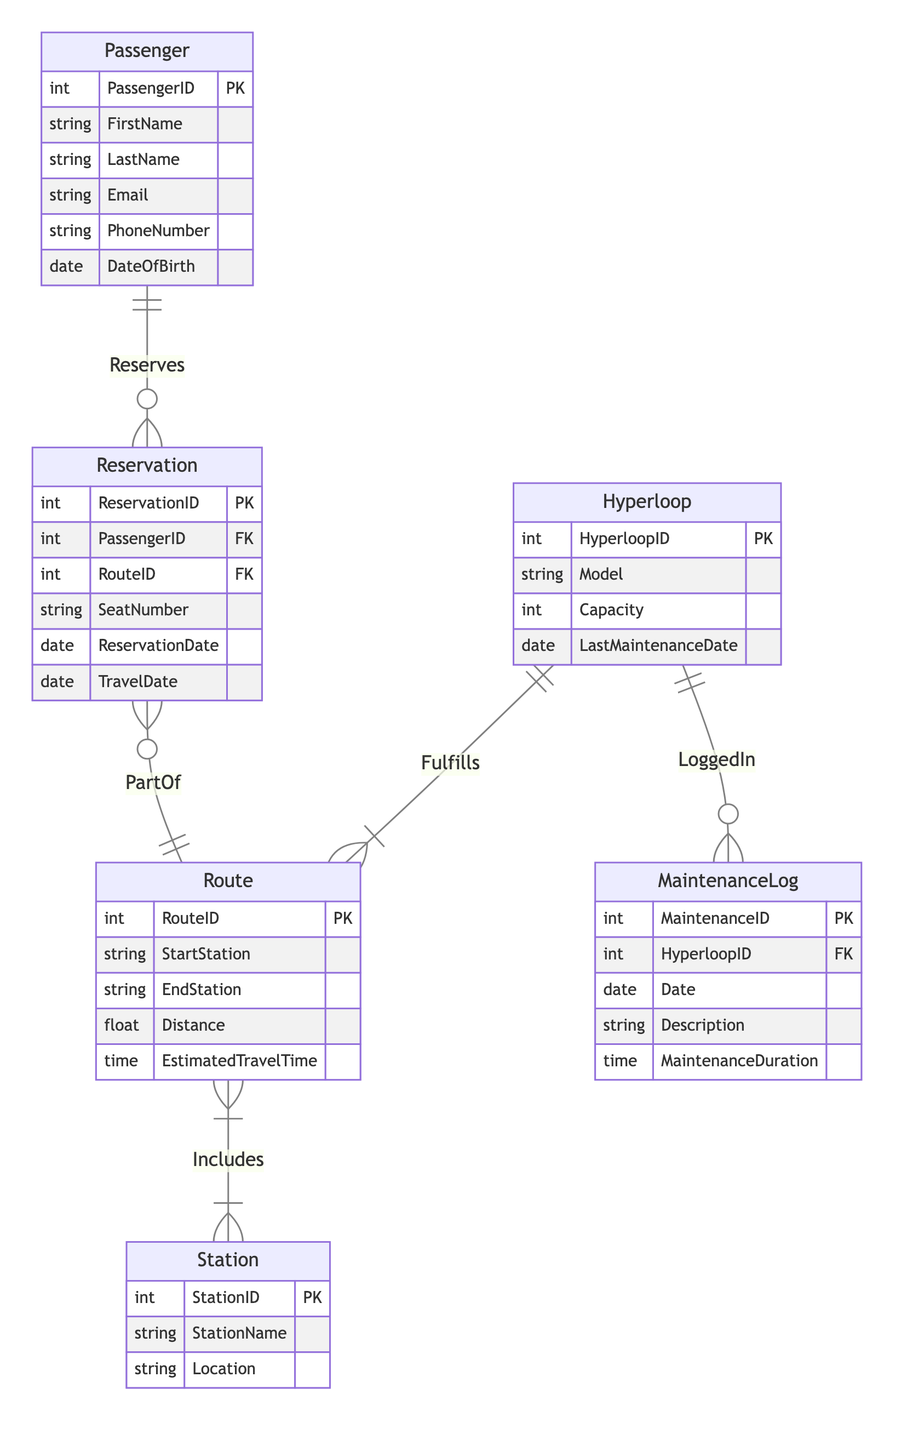What is the primary key of the Passenger entity? The primary key (PK) of the Passenger entity is PassengerID, which uniquely identifies each passenger in the system.
Answer: PassengerID How many attributes does the Route entity have? The Route entity includes five attributes: RouteID, StartStation, EndStation, Distance, and EstimatedTravelTime.
Answer: 5 Which relationship connects Passenger and Reservation? The relationship connecting Passenger and Reservation is labeled as "Reserves," indicating that passengers can have multiple reservations.
Answer: Reserves What type of relationship exists between Route and Station? The relationship between Route and Station is labeled "Includes," which defines a many-to-many relationship, meaning a route can include multiple stations and a station can be part of multiple routes.
Answer: M:N How many maintenance logs can be associated with a single Hyperloop? According to the diagram, one Hyperloop can have many associated MaintenanceLogs, as indicated by the "LoggedIn" relationship which defines a one-to-many connection.
Answer: Many What is the relationship cardinality between Reservation and Route? The cardinality between Reservation and Route is "N:1," meaning that many reservations can be connected to a single route, indicating that multiple passengers can book the same route.
Answer: N:1 Which entity has an attribute for LastMaintenanceDate? The entity Hyperloop contains the attribute LastMaintenanceDate, indicating when the last maintenance occurred for each hyperloop.
Answer: Hyperloop How does the MaintenanceLog entity relate to Hyperloop? The MaintenanceLog entity is related to Hyperloop through the relationship called "LoggedIn," which indicates that each maintenance log is recorded for a specific Hyperloop.
Answer: LoggedIn What is the maximum number of seats a Hyperloop can accommodate? The maximum number of seats is indicated by the Capacity attribute in the Hyperloop entity, determining how many passengers it can carry.
Answer: Capacity 